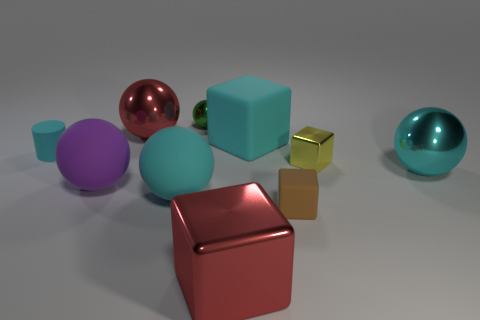Subtract 1 spheres. How many spheres are left? 4 Subtract all green balls. How many balls are left? 4 Subtract all green spheres. How many spheres are left? 4 Subtract all brown spheres. Subtract all red cubes. How many spheres are left? 5 Subtract all cylinders. How many objects are left? 9 Add 2 shiny spheres. How many shiny spheres exist? 5 Subtract 1 red balls. How many objects are left? 9 Subtract all purple objects. Subtract all large purple matte balls. How many objects are left? 8 Add 3 cubes. How many cubes are left? 7 